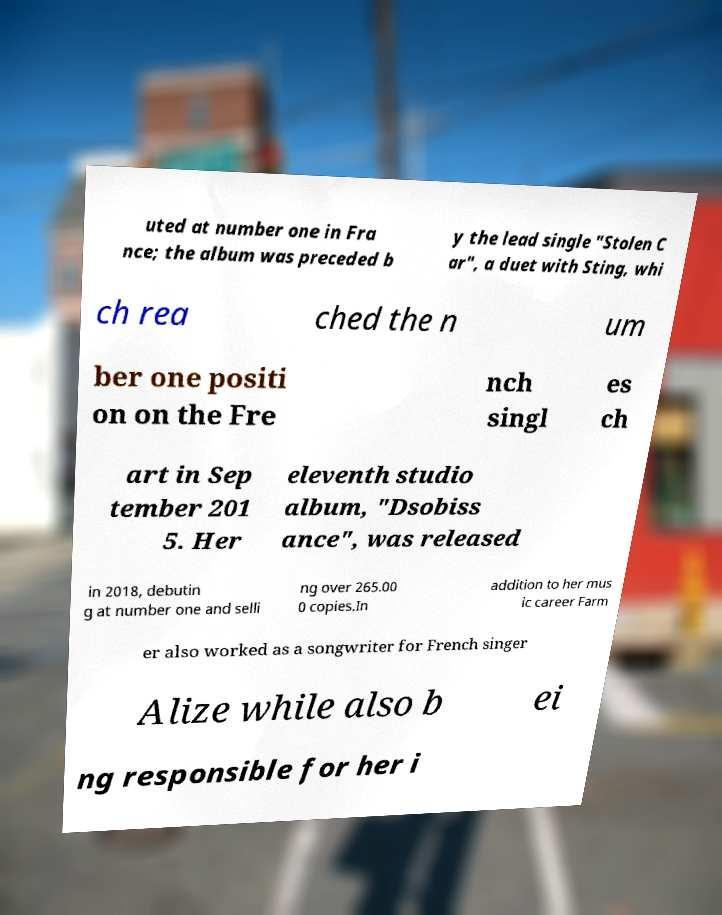What messages or text are displayed in this image? I need them in a readable, typed format. uted at number one in Fra nce; the album was preceded b y the lead single "Stolen C ar", a duet with Sting, whi ch rea ched the n um ber one positi on on the Fre nch singl es ch art in Sep tember 201 5. Her eleventh studio album, "Dsobiss ance", was released in 2018, debutin g at number one and selli ng over 265.00 0 copies.In addition to her mus ic career Farm er also worked as a songwriter for French singer Alize while also b ei ng responsible for her i 